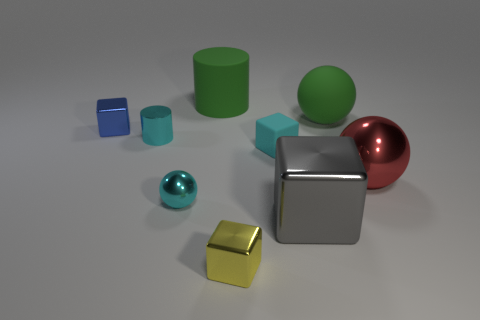Is there anything else that is the same color as the tiny metal cylinder?
Provide a short and direct response. Yes. The matte object that is the same color as the metallic cylinder is what shape?
Offer a terse response. Cube. Is the sphere right of the large green sphere made of the same material as the big cylinder?
Your answer should be very brief. No. The cube that is in front of the tiny blue metal block and behind the cyan metal sphere is made of what material?
Your response must be concise. Rubber. What is the size of the matte cube that is the same color as the metallic cylinder?
Give a very brief answer. Small. What is the material of the cylinder on the right side of the ball in front of the large red object?
Offer a terse response. Rubber. How big is the ball that is on the left side of the matte thing that is in front of the blue metallic cube that is behind the tiny rubber block?
Offer a very short reply. Small. How many big green objects are made of the same material as the small blue cube?
Ensure brevity in your answer.  0. What color is the tiny metallic block that is in front of the thing that is on the right side of the rubber sphere?
Provide a succinct answer. Yellow. What number of objects are small cubes or metal cubes behind the red object?
Your answer should be very brief. 3. 